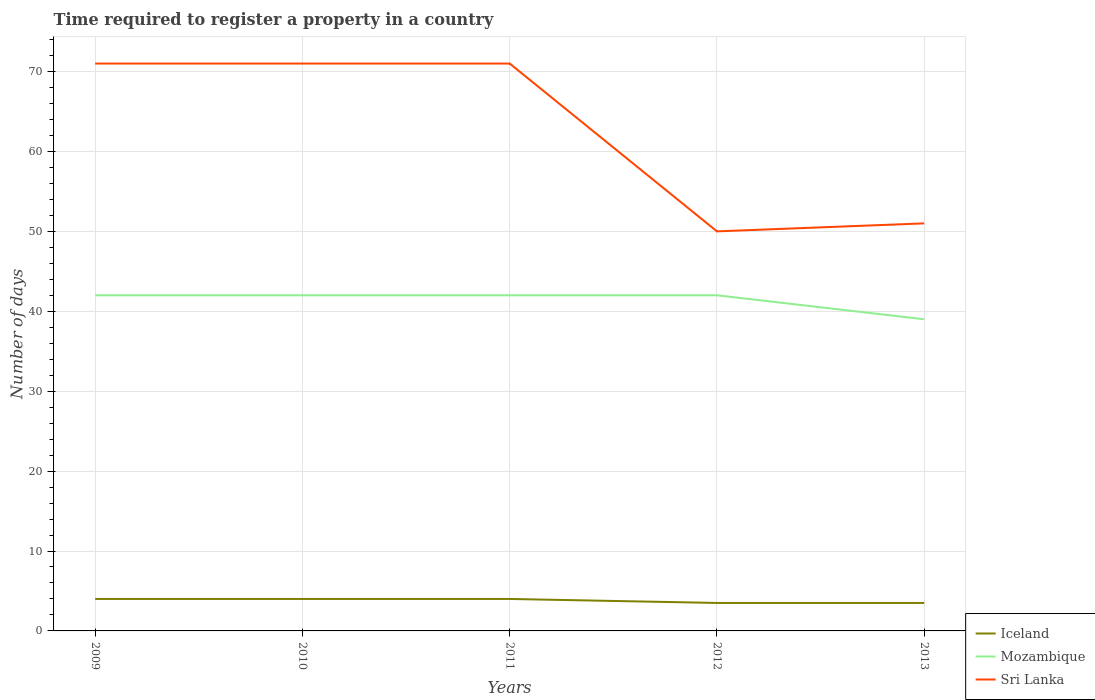How many different coloured lines are there?
Your answer should be very brief. 3. What is the total number of days required to register a property in Iceland in the graph?
Offer a very short reply. 0. What is the difference between the highest and the second highest number of days required to register a property in Sri Lanka?
Keep it short and to the point. 21. What is the difference between the highest and the lowest number of days required to register a property in Iceland?
Make the answer very short. 3. Is the number of days required to register a property in Iceland strictly greater than the number of days required to register a property in Mozambique over the years?
Ensure brevity in your answer.  Yes. How many years are there in the graph?
Ensure brevity in your answer.  5. Does the graph contain grids?
Make the answer very short. Yes. How many legend labels are there?
Provide a short and direct response. 3. How are the legend labels stacked?
Make the answer very short. Vertical. What is the title of the graph?
Offer a very short reply. Time required to register a property in a country. What is the label or title of the Y-axis?
Provide a succinct answer. Number of days. What is the Number of days in Mozambique in 2009?
Your answer should be compact. 42. What is the Number of days of Sri Lanka in 2009?
Offer a very short reply. 71. What is the Number of days in Iceland in 2010?
Ensure brevity in your answer.  4. What is the Number of days in Sri Lanka in 2011?
Your answer should be compact. 71. What is the Number of days in Iceland in 2012?
Give a very brief answer. 3.5. What is the Number of days in Mozambique in 2012?
Provide a succinct answer. 42. What is the Number of days in Sri Lanka in 2012?
Provide a short and direct response. 50. What is the Number of days in Mozambique in 2013?
Your response must be concise. 39. Across all years, what is the maximum Number of days of Iceland?
Ensure brevity in your answer.  4. What is the total Number of days of Iceland in the graph?
Provide a short and direct response. 19. What is the total Number of days in Mozambique in the graph?
Offer a terse response. 207. What is the total Number of days of Sri Lanka in the graph?
Ensure brevity in your answer.  314. What is the difference between the Number of days of Mozambique in 2009 and that in 2010?
Give a very brief answer. 0. What is the difference between the Number of days in Sri Lanka in 2009 and that in 2011?
Your answer should be very brief. 0. What is the difference between the Number of days of Iceland in 2009 and that in 2012?
Provide a short and direct response. 0.5. What is the difference between the Number of days in Sri Lanka in 2009 and that in 2012?
Ensure brevity in your answer.  21. What is the difference between the Number of days of Mozambique in 2009 and that in 2013?
Your response must be concise. 3. What is the difference between the Number of days in Sri Lanka in 2009 and that in 2013?
Your response must be concise. 20. What is the difference between the Number of days in Iceland in 2010 and that in 2011?
Provide a short and direct response. 0. What is the difference between the Number of days in Mozambique in 2010 and that in 2012?
Your response must be concise. 0. What is the difference between the Number of days of Mozambique in 2010 and that in 2013?
Make the answer very short. 3. What is the difference between the Number of days in Sri Lanka in 2010 and that in 2013?
Offer a terse response. 20. What is the difference between the Number of days in Mozambique in 2011 and that in 2012?
Your answer should be compact. 0. What is the difference between the Number of days of Sri Lanka in 2011 and that in 2012?
Offer a very short reply. 21. What is the difference between the Number of days in Iceland in 2011 and that in 2013?
Provide a succinct answer. 0.5. What is the difference between the Number of days of Mozambique in 2011 and that in 2013?
Give a very brief answer. 3. What is the difference between the Number of days in Sri Lanka in 2011 and that in 2013?
Provide a short and direct response. 20. What is the difference between the Number of days of Mozambique in 2012 and that in 2013?
Provide a short and direct response. 3. What is the difference between the Number of days in Sri Lanka in 2012 and that in 2013?
Your response must be concise. -1. What is the difference between the Number of days in Iceland in 2009 and the Number of days in Mozambique in 2010?
Provide a short and direct response. -38. What is the difference between the Number of days in Iceland in 2009 and the Number of days in Sri Lanka in 2010?
Ensure brevity in your answer.  -67. What is the difference between the Number of days of Mozambique in 2009 and the Number of days of Sri Lanka in 2010?
Provide a short and direct response. -29. What is the difference between the Number of days in Iceland in 2009 and the Number of days in Mozambique in 2011?
Your answer should be very brief. -38. What is the difference between the Number of days of Iceland in 2009 and the Number of days of Sri Lanka in 2011?
Make the answer very short. -67. What is the difference between the Number of days in Iceland in 2009 and the Number of days in Mozambique in 2012?
Your answer should be compact. -38. What is the difference between the Number of days in Iceland in 2009 and the Number of days in Sri Lanka in 2012?
Keep it short and to the point. -46. What is the difference between the Number of days of Iceland in 2009 and the Number of days of Mozambique in 2013?
Make the answer very short. -35. What is the difference between the Number of days in Iceland in 2009 and the Number of days in Sri Lanka in 2013?
Give a very brief answer. -47. What is the difference between the Number of days of Iceland in 2010 and the Number of days of Mozambique in 2011?
Provide a succinct answer. -38. What is the difference between the Number of days in Iceland in 2010 and the Number of days in Sri Lanka in 2011?
Keep it short and to the point. -67. What is the difference between the Number of days in Iceland in 2010 and the Number of days in Mozambique in 2012?
Make the answer very short. -38. What is the difference between the Number of days in Iceland in 2010 and the Number of days in Sri Lanka in 2012?
Ensure brevity in your answer.  -46. What is the difference between the Number of days in Mozambique in 2010 and the Number of days in Sri Lanka in 2012?
Provide a short and direct response. -8. What is the difference between the Number of days in Iceland in 2010 and the Number of days in Mozambique in 2013?
Offer a terse response. -35. What is the difference between the Number of days in Iceland in 2010 and the Number of days in Sri Lanka in 2013?
Your response must be concise. -47. What is the difference between the Number of days of Mozambique in 2010 and the Number of days of Sri Lanka in 2013?
Your answer should be compact. -9. What is the difference between the Number of days of Iceland in 2011 and the Number of days of Mozambique in 2012?
Offer a very short reply. -38. What is the difference between the Number of days in Iceland in 2011 and the Number of days in Sri Lanka in 2012?
Your answer should be compact. -46. What is the difference between the Number of days in Iceland in 2011 and the Number of days in Mozambique in 2013?
Provide a succinct answer. -35. What is the difference between the Number of days of Iceland in 2011 and the Number of days of Sri Lanka in 2013?
Give a very brief answer. -47. What is the difference between the Number of days of Iceland in 2012 and the Number of days of Mozambique in 2013?
Provide a short and direct response. -35.5. What is the difference between the Number of days in Iceland in 2012 and the Number of days in Sri Lanka in 2013?
Offer a terse response. -47.5. What is the average Number of days in Mozambique per year?
Make the answer very short. 41.4. What is the average Number of days of Sri Lanka per year?
Offer a very short reply. 62.8. In the year 2009, what is the difference between the Number of days in Iceland and Number of days in Mozambique?
Offer a very short reply. -38. In the year 2009, what is the difference between the Number of days in Iceland and Number of days in Sri Lanka?
Your response must be concise. -67. In the year 2010, what is the difference between the Number of days of Iceland and Number of days of Mozambique?
Your answer should be very brief. -38. In the year 2010, what is the difference between the Number of days of Iceland and Number of days of Sri Lanka?
Ensure brevity in your answer.  -67. In the year 2010, what is the difference between the Number of days of Mozambique and Number of days of Sri Lanka?
Ensure brevity in your answer.  -29. In the year 2011, what is the difference between the Number of days in Iceland and Number of days in Mozambique?
Keep it short and to the point. -38. In the year 2011, what is the difference between the Number of days in Iceland and Number of days in Sri Lanka?
Keep it short and to the point. -67. In the year 2011, what is the difference between the Number of days in Mozambique and Number of days in Sri Lanka?
Provide a succinct answer. -29. In the year 2012, what is the difference between the Number of days of Iceland and Number of days of Mozambique?
Keep it short and to the point. -38.5. In the year 2012, what is the difference between the Number of days of Iceland and Number of days of Sri Lanka?
Your answer should be very brief. -46.5. In the year 2013, what is the difference between the Number of days in Iceland and Number of days in Mozambique?
Keep it short and to the point. -35.5. In the year 2013, what is the difference between the Number of days in Iceland and Number of days in Sri Lanka?
Provide a short and direct response. -47.5. What is the ratio of the Number of days in Iceland in 2009 to that in 2010?
Give a very brief answer. 1. What is the ratio of the Number of days of Mozambique in 2009 to that in 2010?
Your answer should be compact. 1. What is the ratio of the Number of days in Sri Lanka in 2009 to that in 2010?
Your answer should be compact. 1. What is the ratio of the Number of days of Sri Lanka in 2009 to that in 2011?
Your answer should be compact. 1. What is the ratio of the Number of days of Sri Lanka in 2009 to that in 2012?
Offer a very short reply. 1.42. What is the ratio of the Number of days of Mozambique in 2009 to that in 2013?
Offer a very short reply. 1.08. What is the ratio of the Number of days in Sri Lanka in 2009 to that in 2013?
Give a very brief answer. 1.39. What is the ratio of the Number of days in Iceland in 2010 to that in 2011?
Ensure brevity in your answer.  1. What is the ratio of the Number of days in Mozambique in 2010 to that in 2011?
Offer a very short reply. 1. What is the ratio of the Number of days of Sri Lanka in 2010 to that in 2011?
Make the answer very short. 1. What is the ratio of the Number of days of Iceland in 2010 to that in 2012?
Offer a terse response. 1.14. What is the ratio of the Number of days of Mozambique in 2010 to that in 2012?
Make the answer very short. 1. What is the ratio of the Number of days of Sri Lanka in 2010 to that in 2012?
Give a very brief answer. 1.42. What is the ratio of the Number of days in Iceland in 2010 to that in 2013?
Offer a terse response. 1.14. What is the ratio of the Number of days in Sri Lanka in 2010 to that in 2013?
Provide a succinct answer. 1.39. What is the ratio of the Number of days of Iceland in 2011 to that in 2012?
Make the answer very short. 1.14. What is the ratio of the Number of days of Mozambique in 2011 to that in 2012?
Provide a succinct answer. 1. What is the ratio of the Number of days of Sri Lanka in 2011 to that in 2012?
Your answer should be very brief. 1.42. What is the ratio of the Number of days in Sri Lanka in 2011 to that in 2013?
Keep it short and to the point. 1.39. What is the ratio of the Number of days of Iceland in 2012 to that in 2013?
Provide a succinct answer. 1. What is the ratio of the Number of days in Sri Lanka in 2012 to that in 2013?
Provide a succinct answer. 0.98. What is the difference between the highest and the lowest Number of days in Iceland?
Provide a succinct answer. 0.5. What is the difference between the highest and the lowest Number of days in Sri Lanka?
Provide a short and direct response. 21. 